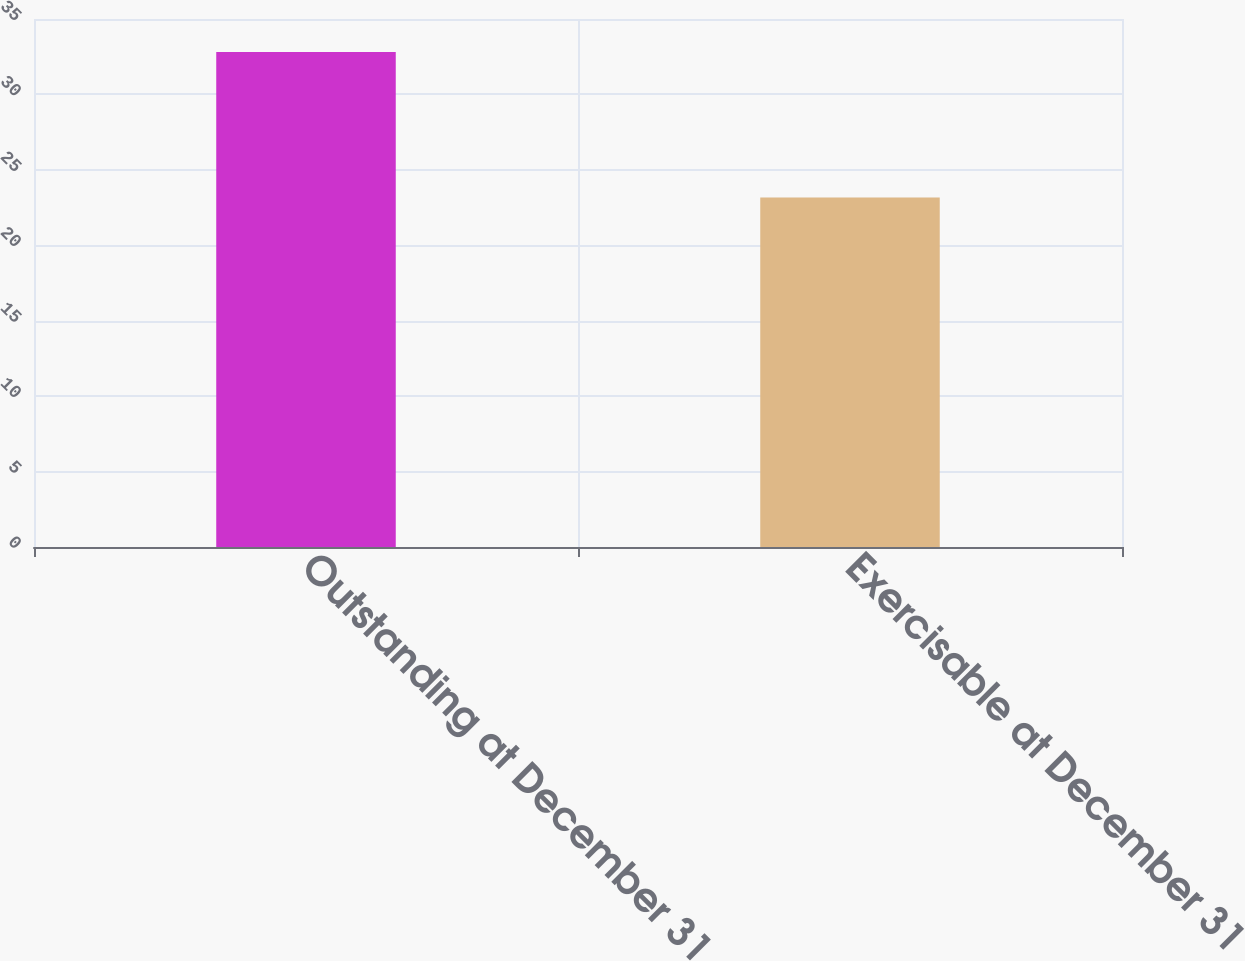Convert chart to OTSL. <chart><loc_0><loc_0><loc_500><loc_500><bar_chart><fcel>Outstanding at December 31<fcel>Exercisable at December 31<nl><fcel>32.81<fcel>23.16<nl></chart> 